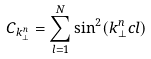<formula> <loc_0><loc_0><loc_500><loc_500>C _ { k _ { \perp } ^ { n } } = \sum _ { l = 1 } ^ { N } \sin ^ { 2 } ( k _ { \perp } ^ { n } c l )</formula> 